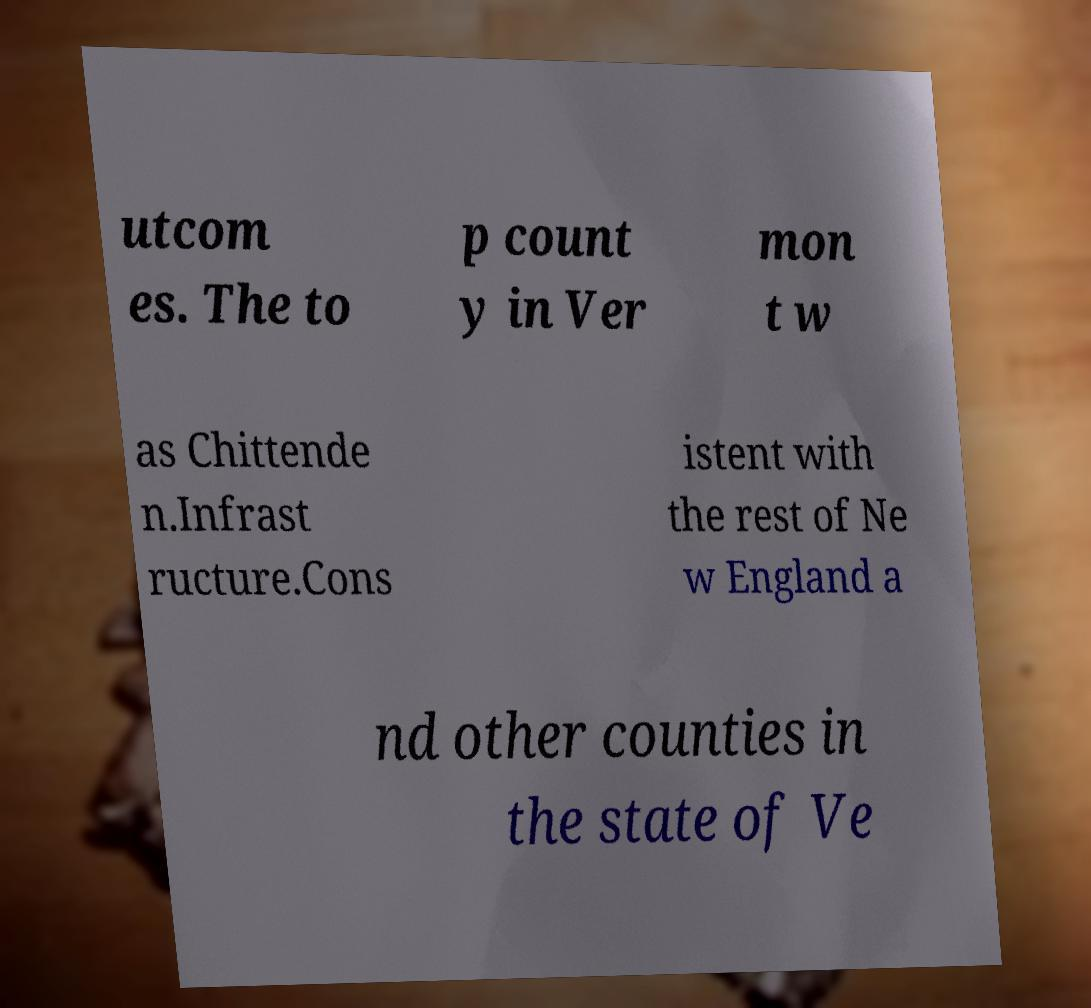Can you accurately transcribe the text from the provided image for me? utcom es. The to p count y in Ver mon t w as Chittende n.Infrast ructure.Cons istent with the rest of Ne w England a nd other counties in the state of Ve 